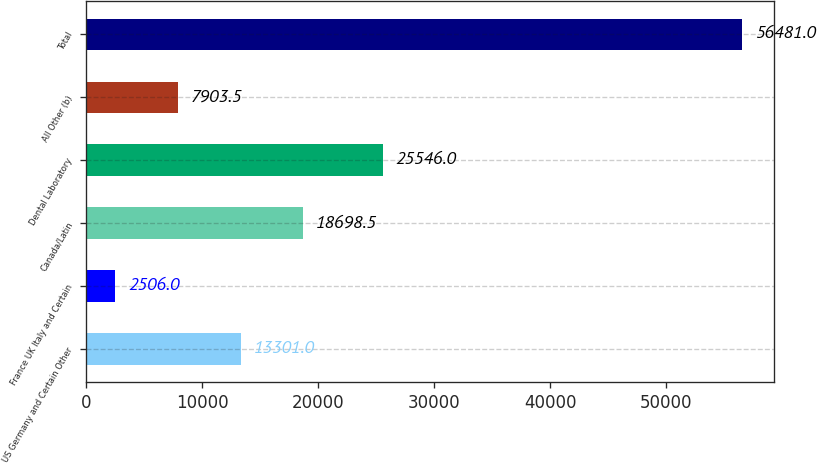<chart> <loc_0><loc_0><loc_500><loc_500><bar_chart><fcel>US Germany and Certain Other<fcel>France UK Italy and Certain<fcel>Canada/Latin<fcel>Dental Laboratory<fcel>All Other (b)<fcel>Total<nl><fcel>13301<fcel>2506<fcel>18698.5<fcel>25546<fcel>7903.5<fcel>56481<nl></chart> 